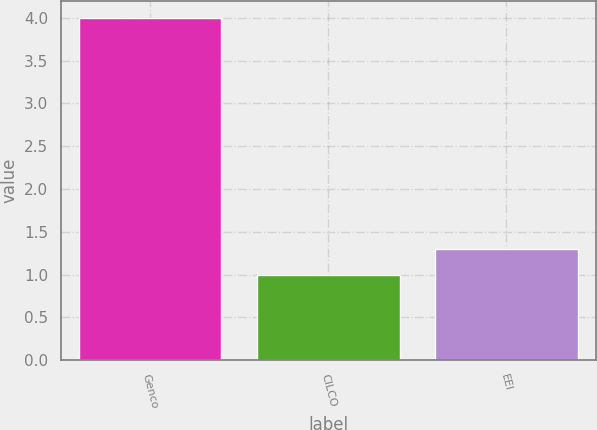<chart> <loc_0><loc_0><loc_500><loc_500><bar_chart><fcel>Genco<fcel>CILCO<fcel>EEI<nl><fcel>4<fcel>1<fcel>1.3<nl></chart> 